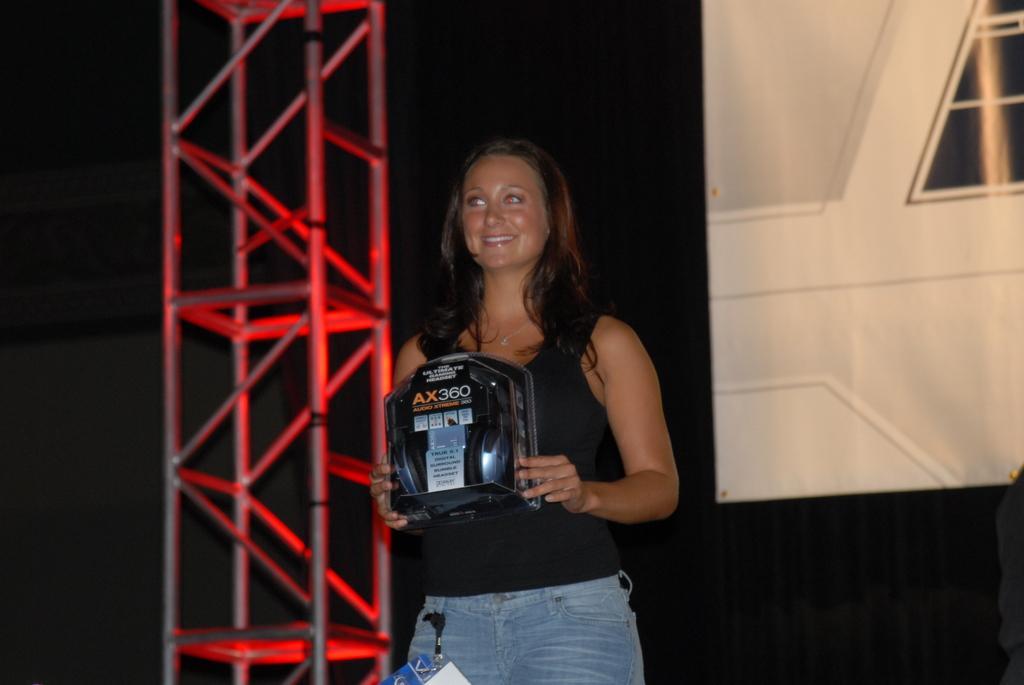How would you summarize this image in a sentence or two? A woman is standing wearing a black t shirt and holding an object. There is a black background. 